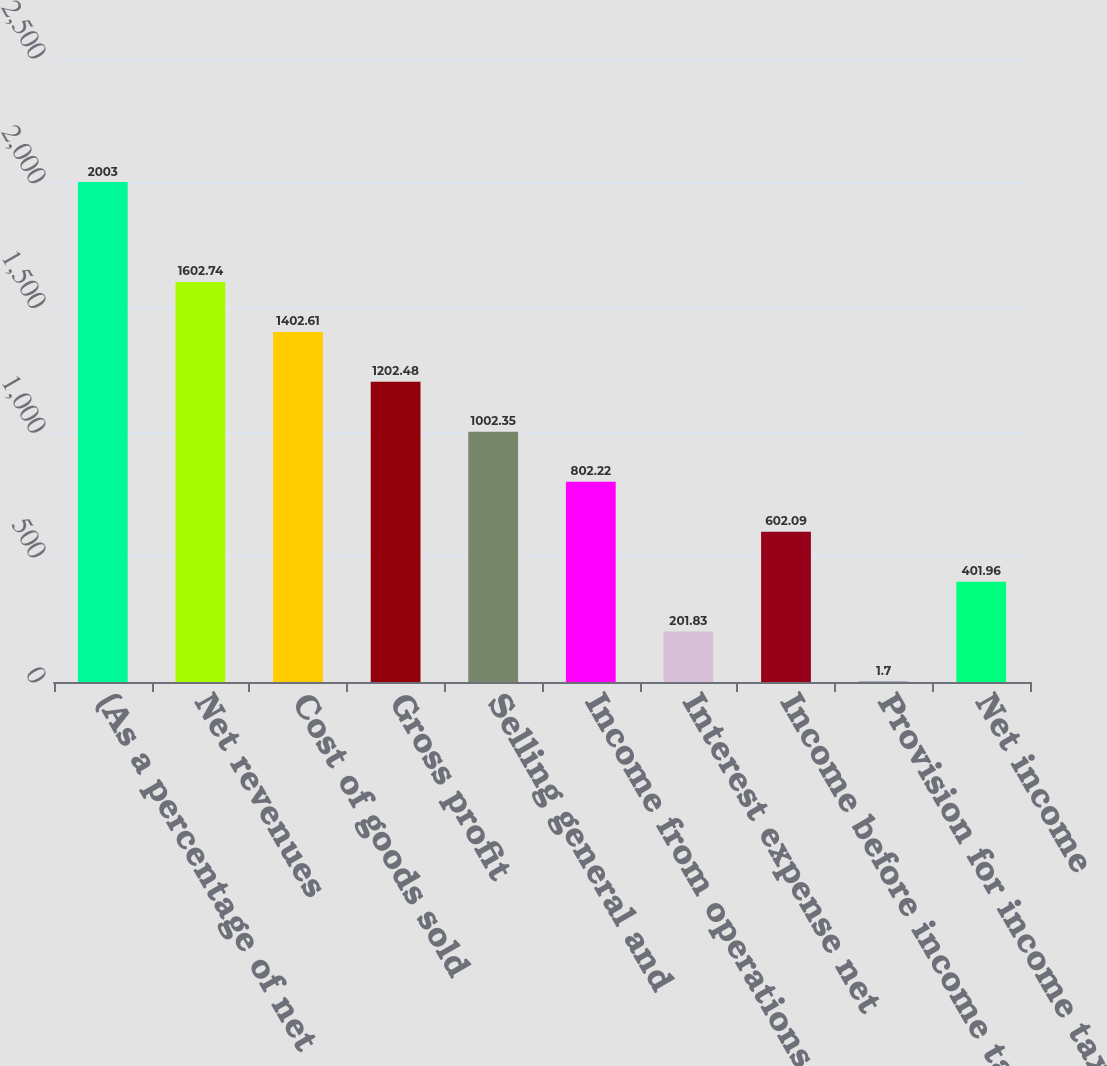Convert chart to OTSL. <chart><loc_0><loc_0><loc_500><loc_500><bar_chart><fcel>(As a percentage of net<fcel>Net revenues<fcel>Cost of goods sold<fcel>Gross profit<fcel>Selling general and<fcel>Income from operations<fcel>Interest expense net<fcel>Income before income taxes<fcel>Provision for income taxes<fcel>Net income<nl><fcel>2003<fcel>1602.74<fcel>1402.61<fcel>1202.48<fcel>1002.35<fcel>802.22<fcel>201.83<fcel>602.09<fcel>1.7<fcel>401.96<nl></chart> 